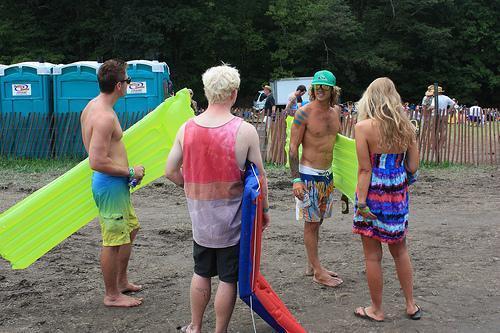How many toilets are there?
Give a very brief answer. 3. 